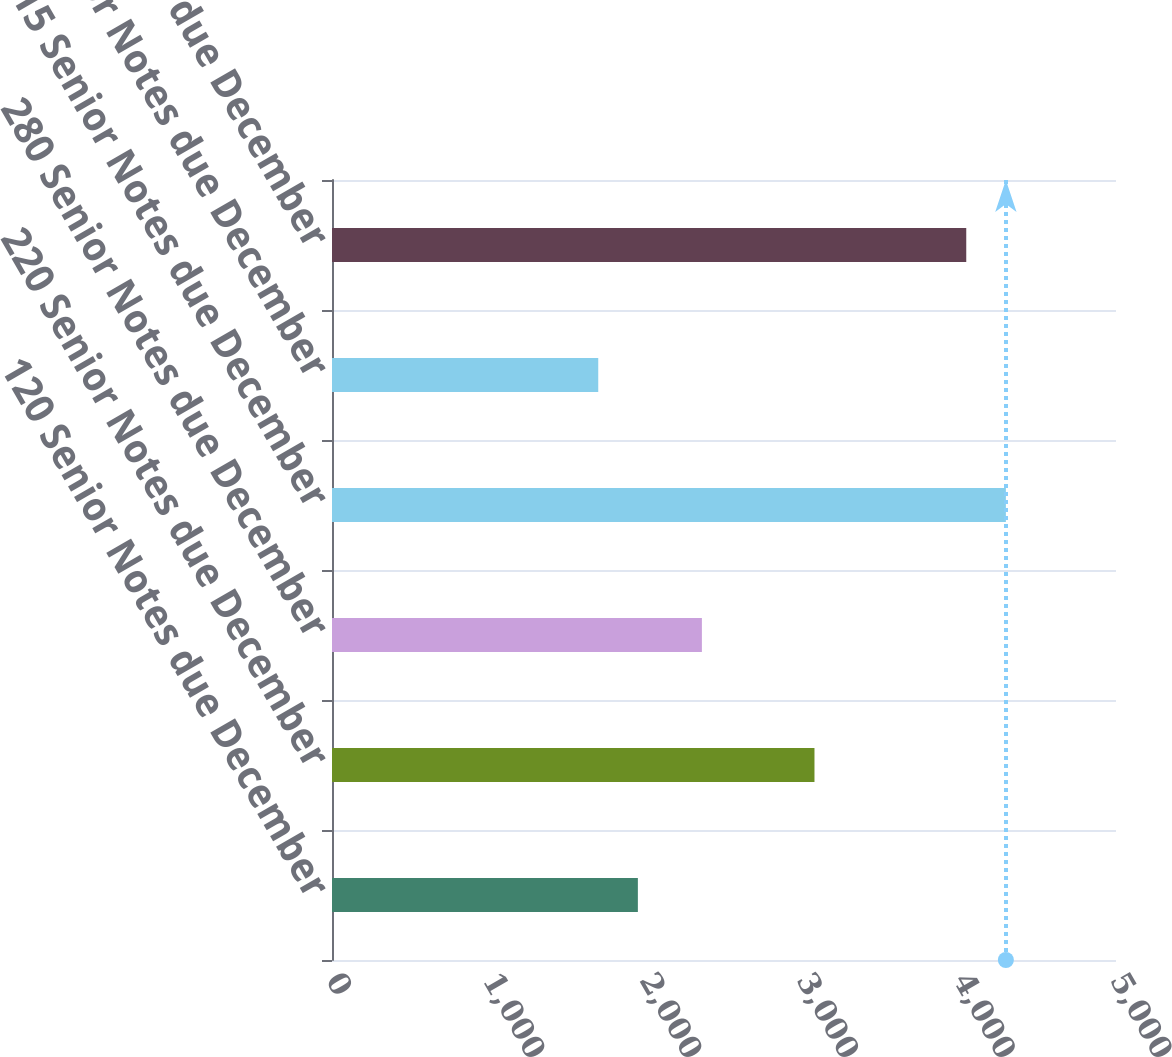<chart> <loc_0><loc_0><loc_500><loc_500><bar_chart><fcel>120 Senior Notes due December<fcel>220 Senior Notes due December<fcel>280 Senior Notes due December<fcel>315 Senior Notes due December<fcel>415 Senior Notes due December<fcel>430 Senior Notes due December<nl><fcel>1950.7<fcel>3077<fcel>2359<fcel>4297.7<fcel>1698<fcel>4045<nl></chart> 